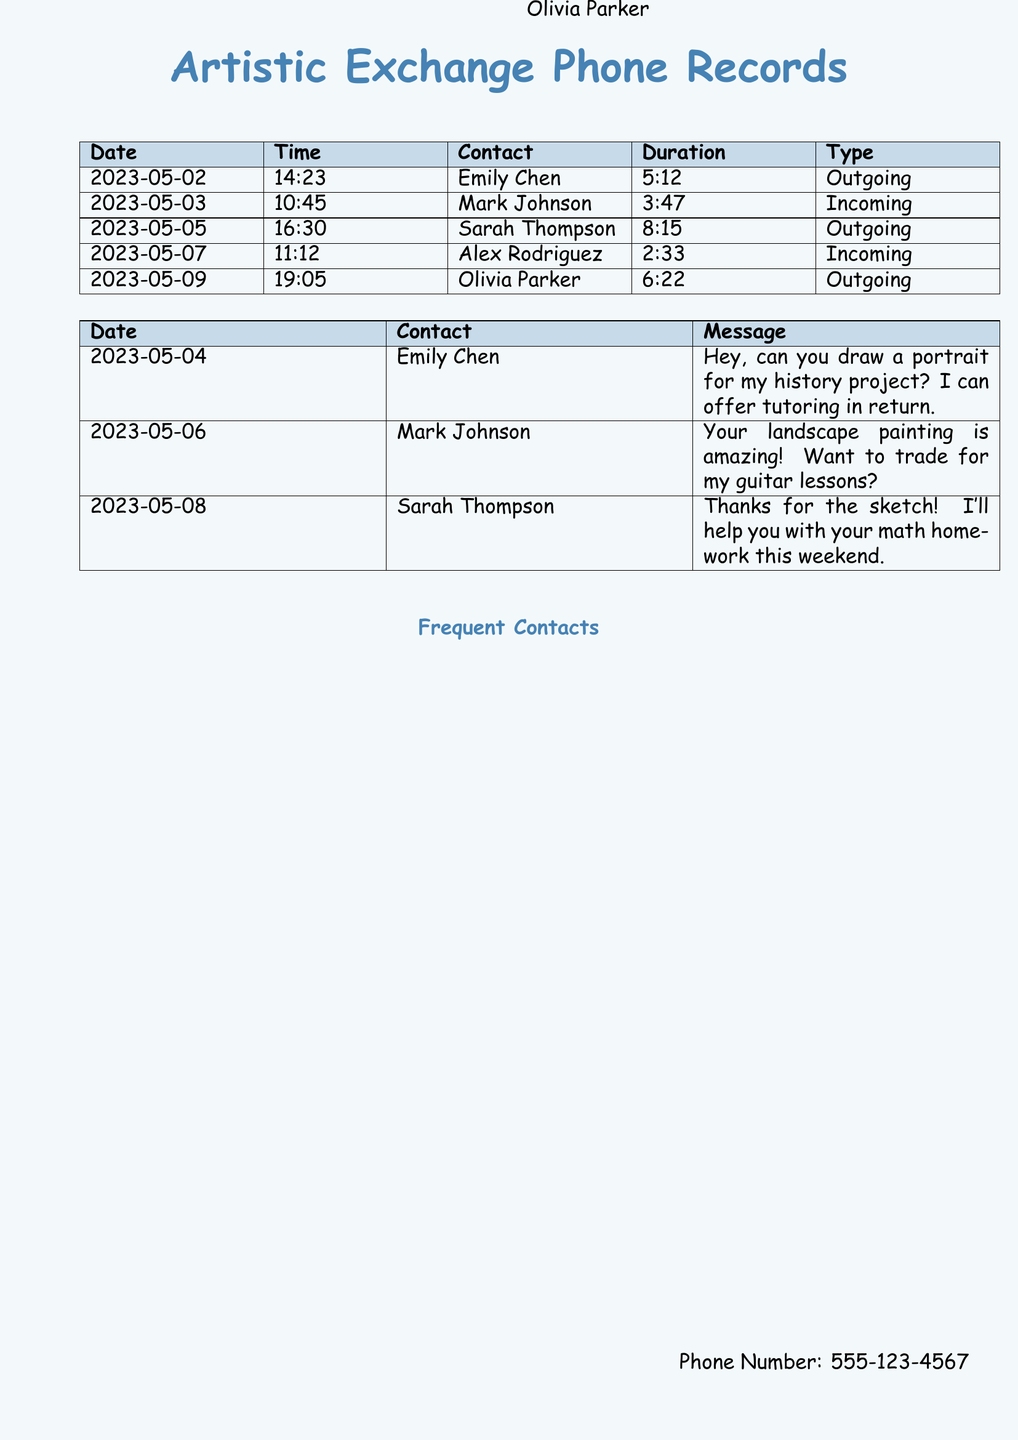what is the date of the first outgoing call? The first outgoing call listed in the document is on May 2, 2023.
Answer: May 2, 2023 who did Sarah Thompson exchange messages with? The document shows a message from Sarah Thompson to the artist, mentioned as receiving thanks for their sketch.
Answer: Unknown how long was the call with Olivia Parker? The call duration with Olivia Parker is specified in the records as 6 minutes and 22 seconds.
Answer: 6:22 what type of message did Mark Johnson send? Mark Johnson's message mentions a trade for guitar lessons in exchange for artwork.
Answer: Trade proposal how many contacts are listed in the frequent contacts section? The frequent contacts section contains a list of five individuals.
Answer: 5 what service did Emily Chen offer in return for a portrait? Emily Chen offered tutoring in exchange for a portrait for her history project.
Answer: Tutoring what was the duration of the call with Alex Rodriguez? The call with Alex Rodriguez lasted 2 minutes and 33 seconds.
Answer: 2:33 what date was the last message sent? The last message recorded was sent on May 8, 2023.
Answer: May 8, 2023 who is the contact with the longest call duration? Sarah Thompson has the longest call duration at 8 minutes and 15 seconds.
Answer: Sarah Thompson 